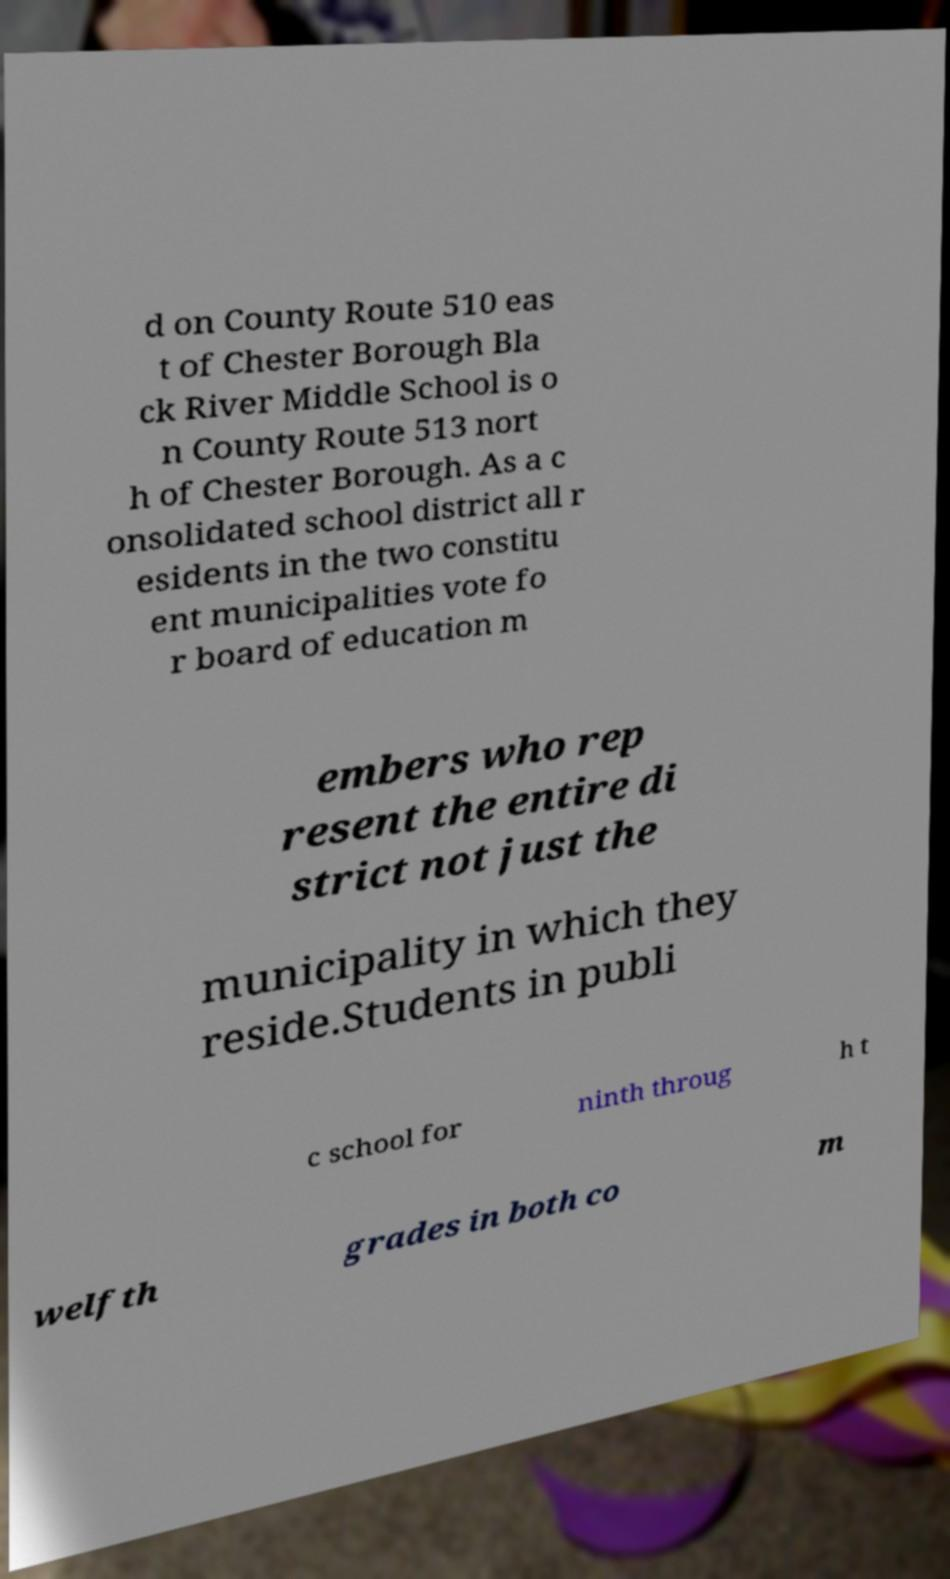Could you assist in decoding the text presented in this image and type it out clearly? d on County Route 510 eas t of Chester Borough Bla ck River Middle School is o n County Route 513 nort h of Chester Borough. As a c onsolidated school district all r esidents in the two constitu ent municipalities vote fo r board of education m embers who rep resent the entire di strict not just the municipality in which they reside.Students in publi c school for ninth throug h t welfth grades in both co m 